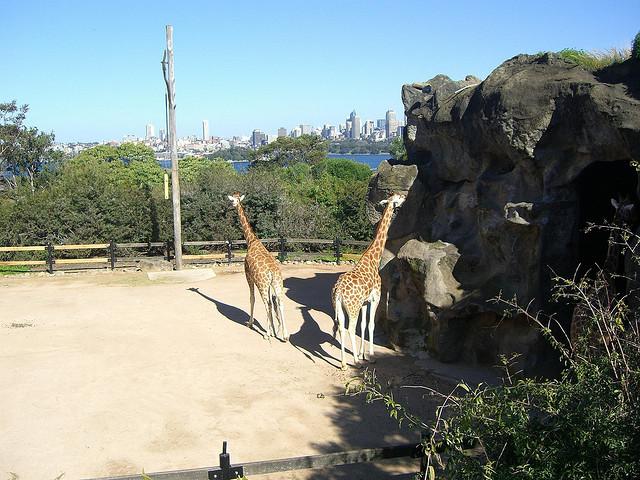Do these giraffes live in the African grasslands?
Be succinct. No. Could this be in the Alps?
Concise answer only. No. How many animals are in the photo?
Be succinct. 2. Which animals are these?
Keep it brief. Giraffes. Are the animals fenced in?
Short answer required. Yes. Is this a zoo?
Be succinct. Yes. What is in the background?
Quick response, please. City. How tall is the giraffe?
Be succinct. 8 feet. How many giraffes are standing?
Concise answer only. 2. 